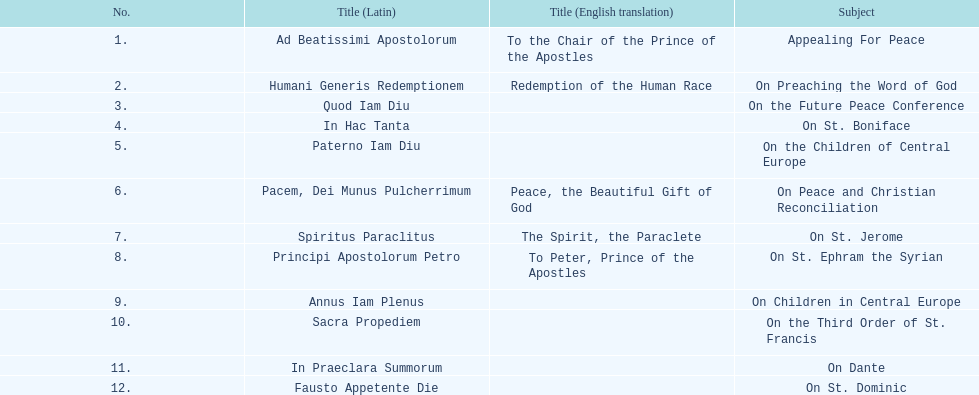How many encyclicals were released in 1921, not counting those in january? 2. 